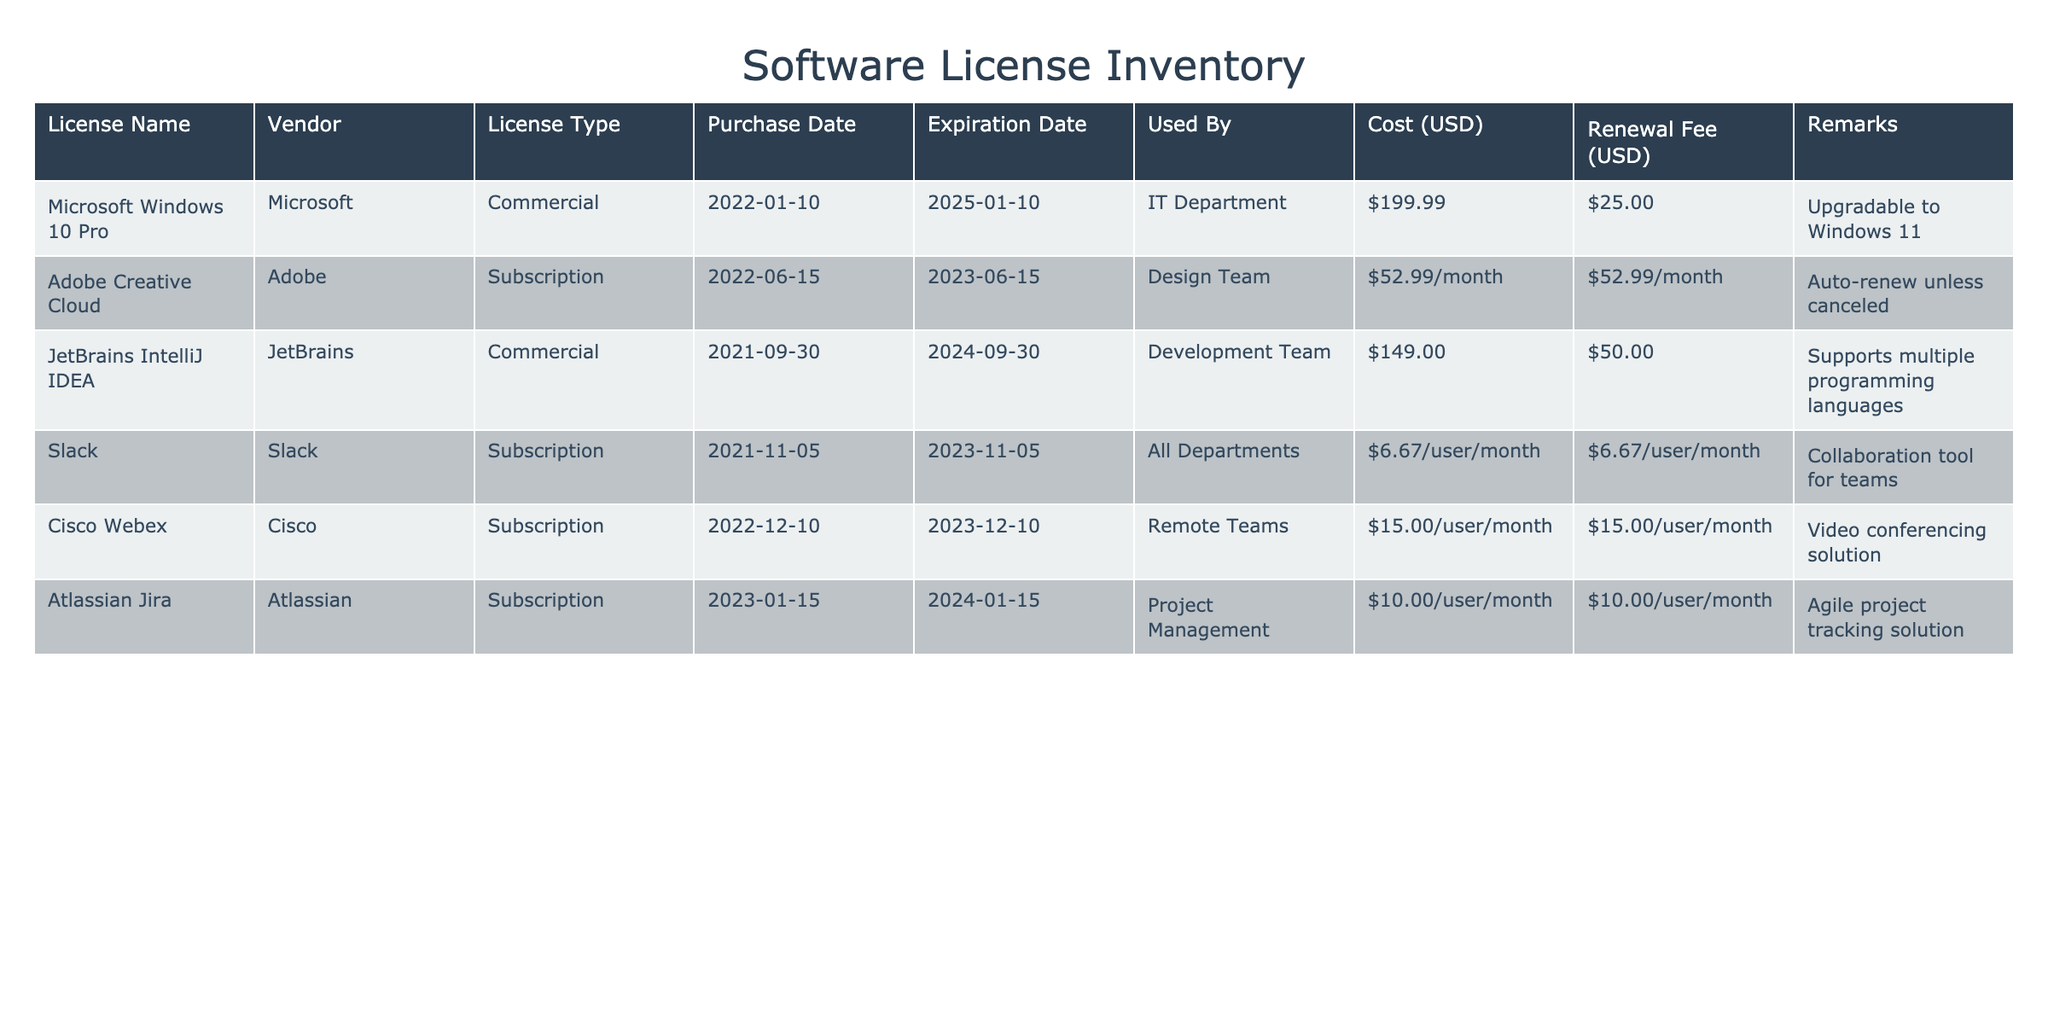What is the expiration date of Slack? The table lists the expiration date of Slack under the "Expiration Date" column, which shows the date as 2023-11-05.
Answer: 2023-11-05 How much does it cost per month to use Adobe Creative Cloud? The cost for Adobe Creative Cloud is listed as 52.99/month in the "Cost (USD)" column, showing the monthly expense for the subscription.
Answer: 52.99/month Are there any licenses that expire in 2023? By checking the "Expiration Date" column, we can see that both Adobe Creative Cloud and Slack have expiration dates in 2023, confirming that there are licenses expiring this year.
Answer: Yes What is the total renewal fee for all licenses that expire in 2024? The licenses expiring in 2024 are JetBrains IntelliJ IDEA (50.00 USD) and Atlassian Jira (10.00/user/month). Assuming 1 user for Jira, the total renewal fee is 50.00 + 10.00 = 60.00.
Answer: 60.00 Which license has the highest one-time purchase cost? Looking at the "Cost (USD)" column, Microsoft Windows 10 Pro has the highest cost at 199.99 USD, making it the most expensive one-time purchase license.
Answer: Microsoft Windows 10 Pro What are the vendors for licenses expiring in 2023? The licenses expiring in 2023 (Adobe Creative Cloud and Slack) have vendors listed as Adobe and Slack, respectively, so the vendors are Adobe and Slack.
Answer: Adobe, Slack Which license offers the potential for an upgrade and what is the new version? The license Microsoft Windows 10 Pro allows an upgrade to Windows 11, as mentioned in the "Remarks" column.
Answer: Windows 11 What is the average cost of all licenses in the table? To find the total cost, we need to sum the costs: 199.99 (Windows) + (52.99 * 12 for Adobe) + 149.00 (JetBrains) + 6.67 * 12 (Slack) + (15.00 * user count for Webex) + (10.00 * user count for Jira). After calculating, divide by the number of licenses to find the average.
Answer: (Average to be computed based on assumptions) 